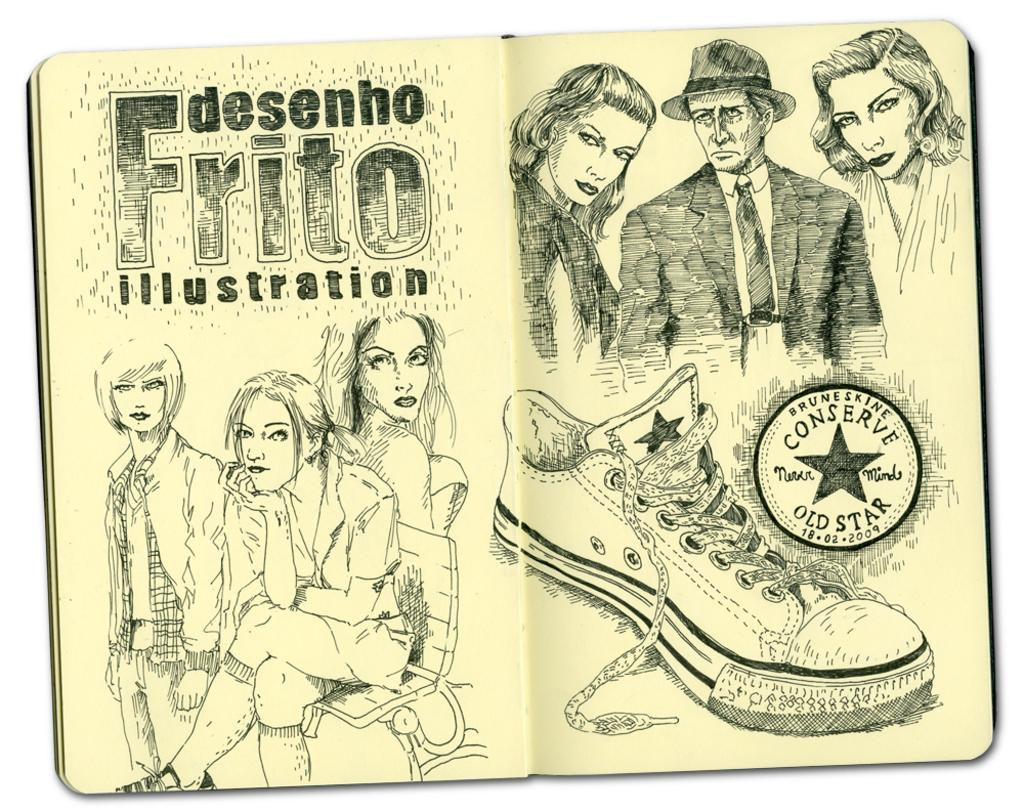What is the main object in the image? There is a book in the image. What type of content is in the book? The book contains a drawing sketch of persons and a sketch of a shoe. Is there any text in the book? Yes, there is text on the book. How many eyes can be seen in the image? There are no eyes visible in the image; it features a book with sketches and text. What type of care is being provided in the image? There is no indication of care being provided in the image; it features a book with sketches and text. 